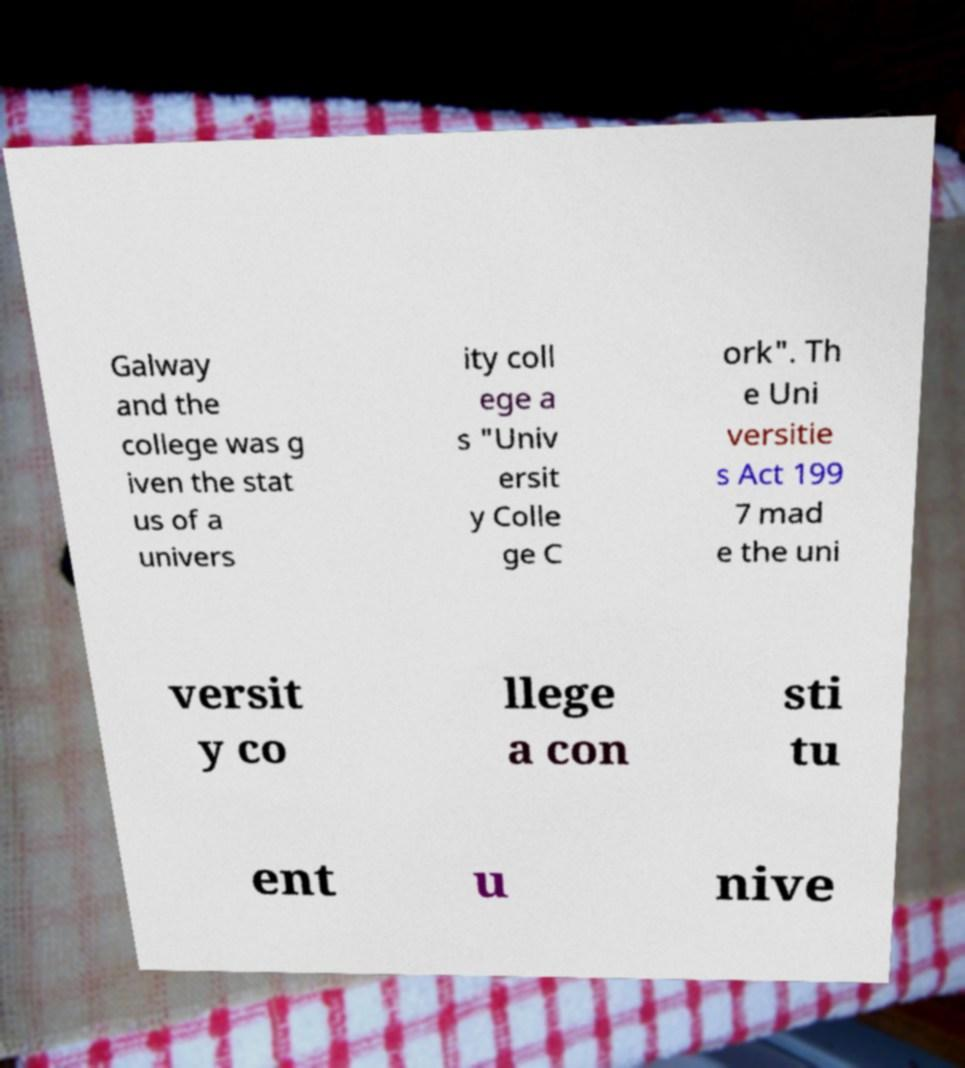Please read and relay the text visible in this image. What does it say? Galway and the college was g iven the stat us of a univers ity coll ege a s "Univ ersit y Colle ge C ork". Th e Uni versitie s Act 199 7 mad e the uni versit y co llege a con sti tu ent u nive 